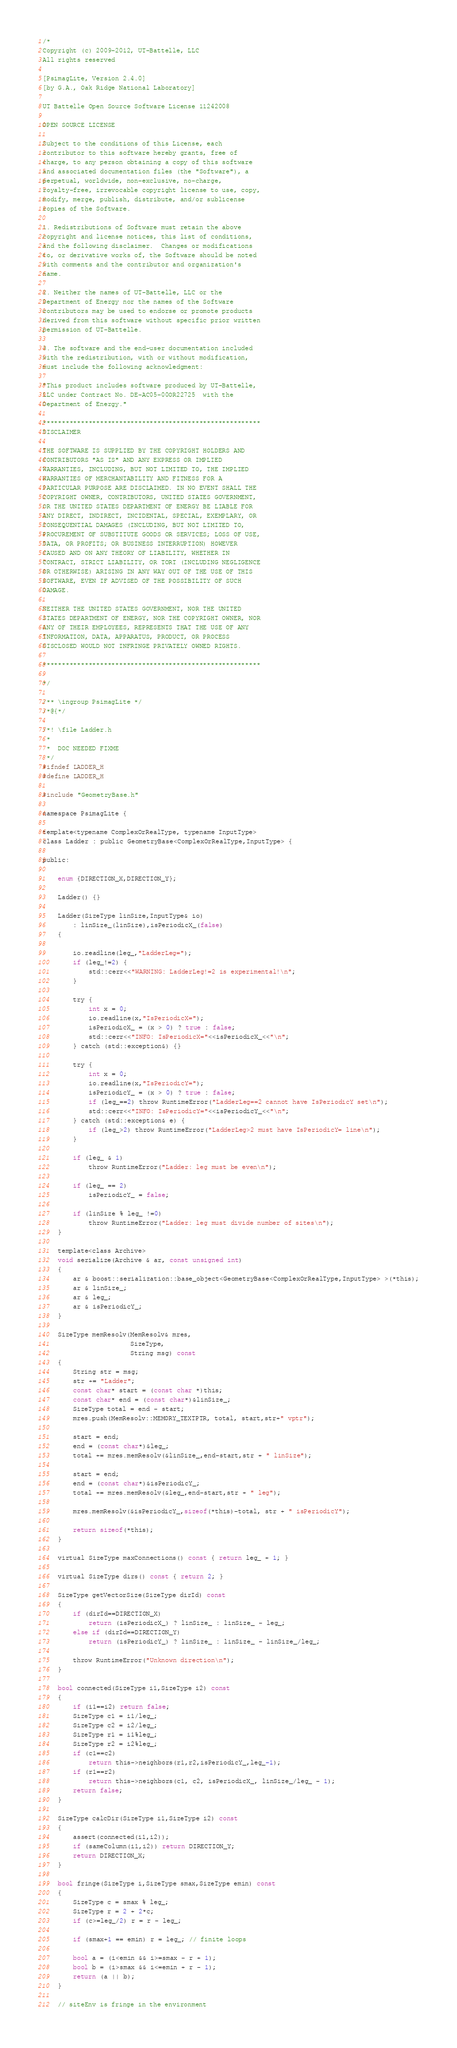<code> <loc_0><loc_0><loc_500><loc_500><_C_>/*
Copyright (c) 2009-2012, UT-Battelle, LLC
All rights reserved

[PsimagLite, Version 2.4.0]
[by G.A., Oak Ridge National Laboratory]

UT Battelle Open Source Software License 11242008

OPEN SOURCE LICENSE

Subject to the conditions of this License, each
contributor to this software hereby grants, free of
charge, to any person obtaining a copy of this software
and associated documentation files (the "Software"), a
perpetual, worldwide, non-exclusive, no-charge,
royalty-free, irrevocable copyright license to use, copy,
modify, merge, publish, distribute, and/or sublicense
copies of the Software.

1. Redistributions of Software must retain the above
copyright and license notices, this list of conditions,
and the following disclaimer.  Changes or modifications
to, or derivative works of, the Software should be noted
with comments and the contributor and organization's
name.

2. Neither the names of UT-Battelle, LLC or the
Department of Energy nor the names of the Software
contributors may be used to endorse or promote products
derived from this software without specific prior written
permission of UT-Battelle.

3. The software and the end-user documentation included
with the redistribution, with or without modification,
must include the following acknowledgment:

"This product includes software produced by UT-Battelle,
LLC under Contract No. DE-AC05-00OR22725  with the
Department of Energy."

*********************************************************
DISCLAIMER

THE SOFTWARE IS SUPPLIED BY THE COPYRIGHT HOLDERS AND
CONTRIBUTORS "AS IS" AND ANY EXPRESS OR IMPLIED
WARRANTIES, INCLUDING, BUT NOT LIMITED TO, THE IMPLIED
WARRANTIES OF MERCHANTABILITY AND FITNESS FOR A
PARTICULAR PURPOSE ARE DISCLAIMED. IN NO EVENT SHALL THE
COPYRIGHT OWNER, CONTRIBUTORS, UNITED STATES GOVERNMENT,
OR THE UNITED STATES DEPARTMENT OF ENERGY BE LIABLE FOR
ANY DIRECT, INDIRECT, INCIDENTAL, SPECIAL, EXEMPLARY, OR
CONSEQUENTIAL DAMAGES (INCLUDING, BUT NOT LIMITED TO,
PROCUREMENT OF SUBSTITUTE GOODS OR SERVICES; LOSS OF USE,
DATA, OR PROFITS; OR BUSINESS INTERRUPTION) HOWEVER
CAUSED AND ON ANY THEORY OF LIABILITY, WHETHER IN
CONTRACT, STRICT LIABILITY, OR TORT (INCLUDING NEGLIGENCE
OR OTHERWISE) ARISING IN ANY WAY OUT OF THE USE OF THIS
SOFTWARE, EVEN IF ADVISED OF THE POSSIBILITY OF SUCH
DAMAGE.

NEITHER THE UNITED STATES GOVERNMENT, NOR THE UNITED
STATES DEPARTMENT OF ENERGY, NOR THE COPYRIGHT OWNER, NOR
ANY OF THEIR EMPLOYEES, REPRESENTS THAT THE USE OF ANY
INFORMATION, DATA, APPARATUS, PRODUCT, OR PROCESS
DISCLOSED WOULD NOT INFRINGE PRIVATELY OWNED RIGHTS.

*********************************************************

*/

/** \ingroup PsimagLite */
/*@{*/

/*! \file Ladder.h
 *
 *  DOC NEEDED FIXME
 */
#ifndef LADDER_H
#define LADDER_H

#include "GeometryBase.h"

namespace PsimagLite {

template<typename ComplexOrRealType, typename InputType>
class Ladder : public GeometryBase<ComplexOrRealType,InputType> {

public:

	enum {DIRECTION_X,DIRECTION_Y};

	Ladder() {}

	Ladder(SizeType linSize,InputType& io)
	    : linSize_(linSize),isPeriodicX_(false)
	{

		io.readline(leg_,"LadderLeg=");
		if (leg_!=2) {
			std::cerr<<"WARNING: LadderLeg!=2 is experimental!\n";
		}

		try {
			int x = 0;
			io.readline(x,"IsPeriodicX=");
			isPeriodicX_ = (x > 0) ? true : false;
			std::cerr<<"INFO: IsPeriodicX="<<isPeriodicX_<<"\n";
		} catch (std::exception&) {}

		try {
			int x = 0;
			io.readline(x,"IsPeriodicY=");
			isPeriodicY_ = (x > 0) ? true : false;
			if (leg_==2) throw RuntimeError("LadderLeg==2 cannot have IsPeriodicY set\n");
			std::cerr<<"INFO: IsPeriodicY="<<isPeriodicY_<<"\n";
		} catch (std::exception& e) {
			if (leg_>2) throw RuntimeError("LadderLeg>2 must have IsPeriodicY= line\n");
		}

		if (leg_ & 1)
			throw RuntimeError("Ladder: leg must be even\n");

		if (leg_ == 2)
			isPeriodicY_ = false;

		if (linSize % leg_ !=0)
			throw RuntimeError("Ladder: leg must divide number of sites\n");
	}

	template<class Archive>
	void serialize(Archive & ar, const unsigned int)
	{
		ar & boost::serialization::base_object<GeometryBase<ComplexOrRealType,InputType> >(*this);
		ar & linSize_;
		ar & leg_;
		ar & isPeriodicY_;
	}

	SizeType memResolv(MemResolv& mres,
	                   SizeType,
	                   String msg) const
	{
		String str = msg;
		str += "Ladder";
		const char* start = (const char *)this;
		const char* end = (const char*)&linSize_;
		SizeType total = end - start;
		mres.push(MemResolv::MEMORY_TEXTPTR, total, start,str+" vptr");

		start = end;
		end = (const char*)&leg_;
		total += mres.memResolv(&linSize_,end-start,str + " linSize");

		start = end;
		end = (const char*)&isPeriodicY_;
		total += mres.memResolv(&leg_,end-start,str + " leg");

		mres.memResolv(&isPeriodicY_,sizeof(*this)-total, str + " isPeriodicY");

		return sizeof(*this);
	}

	virtual SizeType maxConnections() const { return leg_ + 1; }

	virtual SizeType dirs() const { return 2; }

	SizeType getVectorSize(SizeType dirId) const
	{
		if (dirId==DIRECTION_X)
			return (isPeriodicX_) ? linSize_ : linSize_ - leg_;
		else if (dirId==DIRECTION_Y)
			return (isPeriodicY_) ? linSize_ : linSize_ - linSize_/leg_;

		throw RuntimeError("Unknown direction\n");
	}

	bool connected(SizeType i1,SizeType i2) const
	{
		if (i1==i2) return false;
		SizeType c1 = i1/leg_;
		SizeType c2 = i2/leg_;
		SizeType r1 = i1%leg_;
		SizeType r2 = i2%leg_;
		if (c1==c2)
			return this->neighbors(r1,r2,isPeriodicY_,leg_-1);
		if (r1==r2)
			return this->neighbors(c1, c2, isPeriodicX_, linSize_/leg_ - 1);
		return false;
	}

	SizeType calcDir(SizeType i1,SizeType i2) const
	{
		assert(connected(i1,i2));
		if (sameColumn(i1,i2)) return DIRECTION_Y;
		return DIRECTION_X;
	}

	bool fringe(SizeType i,SizeType smax,SizeType emin) const
	{
		SizeType c = smax % leg_;
		SizeType r = 2 + 2*c;
		if (c>=leg_/2) r = r - leg_;

		if (smax+1 == emin) r = leg_; // finite loops

		bool a = (i<emin && i>=smax - r + 1);
		bool b = (i>smax && i<=emin + r - 1);
		return (a || b);
	}

	// siteEnv is fringe in the environment</code> 